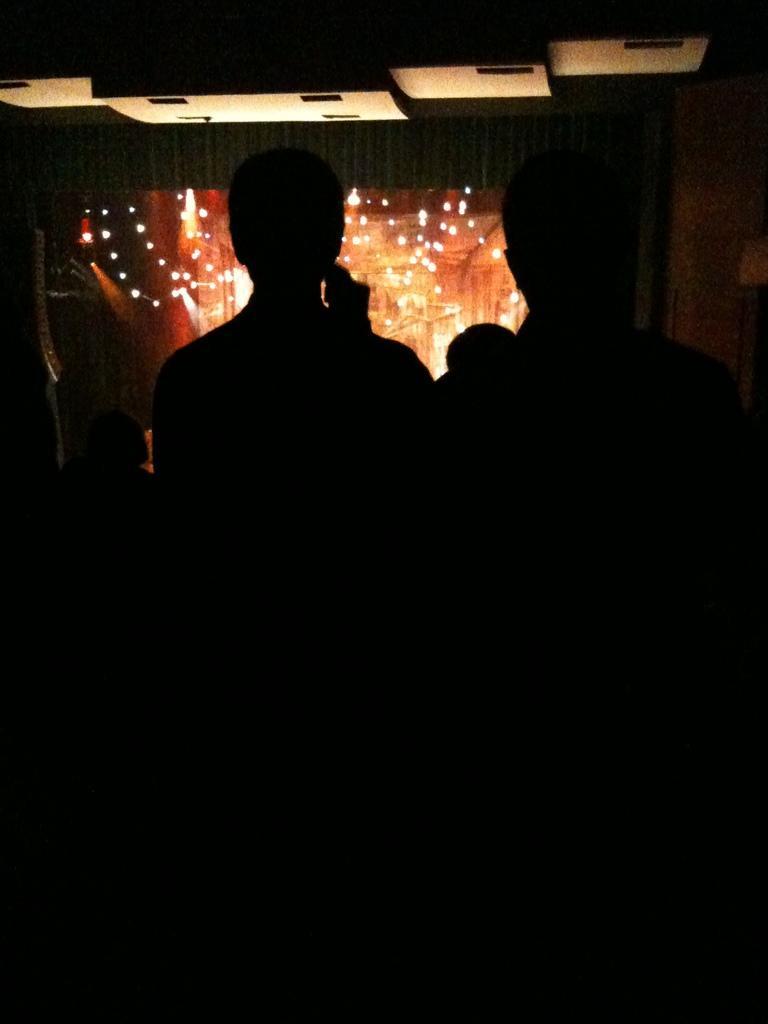In one or two sentences, can you explain what this image depicts? In this picture we can see few people, in the background we can find few lights. 